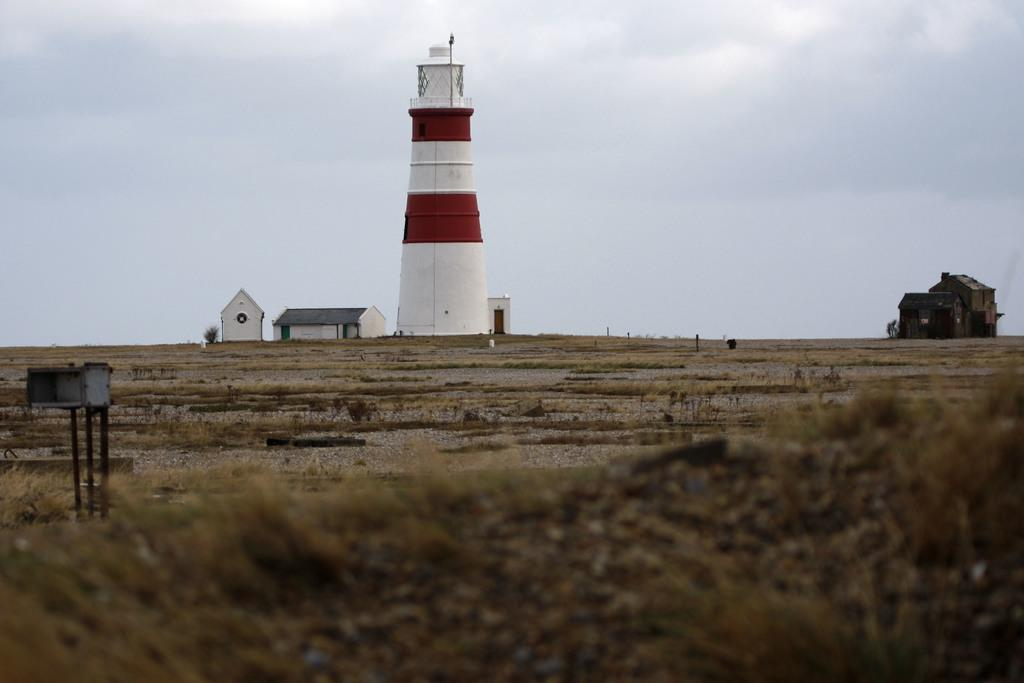What is the main object in the image? There is an object in the image, but its specific nature is not mentioned in the facts. What type of ground is visible in the image? There is grass on the ground in the image. What can be seen in the background of the image? In the background of the image, there is a tower house, houses, plants, and clouds in the sky. How many ladybugs are crawling on the object in the image? There is no mention of ladybugs in the image, so we cannot determine their presence or number. 